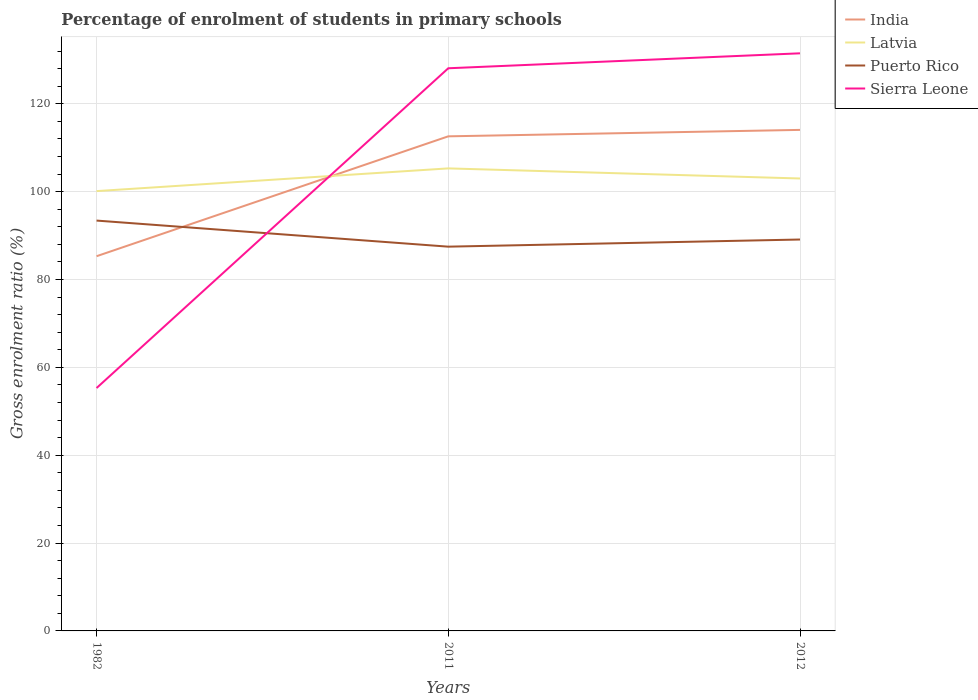Does the line corresponding to India intersect with the line corresponding to Sierra Leone?
Offer a very short reply. Yes. Is the number of lines equal to the number of legend labels?
Your response must be concise. Yes. Across all years, what is the maximum percentage of students enrolled in primary schools in Puerto Rico?
Provide a succinct answer. 87.48. What is the total percentage of students enrolled in primary schools in Latvia in the graph?
Ensure brevity in your answer.  2.3. What is the difference between the highest and the second highest percentage of students enrolled in primary schools in Puerto Rico?
Keep it short and to the point. 5.94. What is the difference between the highest and the lowest percentage of students enrolled in primary schools in India?
Keep it short and to the point. 2. Is the percentage of students enrolled in primary schools in Sierra Leone strictly greater than the percentage of students enrolled in primary schools in Latvia over the years?
Give a very brief answer. No. How many lines are there?
Keep it short and to the point. 4. How many years are there in the graph?
Your response must be concise. 3. What is the difference between two consecutive major ticks on the Y-axis?
Offer a terse response. 20. Are the values on the major ticks of Y-axis written in scientific E-notation?
Your answer should be compact. No. Does the graph contain grids?
Offer a terse response. Yes. Where does the legend appear in the graph?
Provide a succinct answer. Top right. How many legend labels are there?
Ensure brevity in your answer.  4. What is the title of the graph?
Give a very brief answer. Percentage of enrolment of students in primary schools. What is the label or title of the X-axis?
Your response must be concise. Years. What is the Gross enrolment ratio (%) in India in 1982?
Offer a very short reply. 85.3. What is the Gross enrolment ratio (%) of Latvia in 1982?
Keep it short and to the point. 100.13. What is the Gross enrolment ratio (%) of Puerto Rico in 1982?
Your answer should be compact. 93.42. What is the Gross enrolment ratio (%) of Sierra Leone in 1982?
Give a very brief answer. 55.29. What is the Gross enrolment ratio (%) of India in 2011?
Make the answer very short. 112.6. What is the Gross enrolment ratio (%) of Latvia in 2011?
Make the answer very short. 105.3. What is the Gross enrolment ratio (%) in Puerto Rico in 2011?
Your answer should be compact. 87.48. What is the Gross enrolment ratio (%) of Sierra Leone in 2011?
Provide a short and direct response. 128.09. What is the Gross enrolment ratio (%) in India in 2012?
Your answer should be compact. 114.06. What is the Gross enrolment ratio (%) in Latvia in 2012?
Offer a terse response. 103. What is the Gross enrolment ratio (%) in Puerto Rico in 2012?
Ensure brevity in your answer.  89.11. What is the Gross enrolment ratio (%) of Sierra Leone in 2012?
Your answer should be compact. 131.49. Across all years, what is the maximum Gross enrolment ratio (%) in India?
Provide a succinct answer. 114.06. Across all years, what is the maximum Gross enrolment ratio (%) in Latvia?
Give a very brief answer. 105.3. Across all years, what is the maximum Gross enrolment ratio (%) of Puerto Rico?
Keep it short and to the point. 93.42. Across all years, what is the maximum Gross enrolment ratio (%) in Sierra Leone?
Offer a terse response. 131.49. Across all years, what is the minimum Gross enrolment ratio (%) in India?
Keep it short and to the point. 85.3. Across all years, what is the minimum Gross enrolment ratio (%) in Latvia?
Your answer should be very brief. 100.13. Across all years, what is the minimum Gross enrolment ratio (%) of Puerto Rico?
Provide a succinct answer. 87.48. Across all years, what is the minimum Gross enrolment ratio (%) of Sierra Leone?
Make the answer very short. 55.29. What is the total Gross enrolment ratio (%) of India in the graph?
Provide a succinct answer. 311.96. What is the total Gross enrolment ratio (%) of Latvia in the graph?
Ensure brevity in your answer.  308.42. What is the total Gross enrolment ratio (%) in Puerto Rico in the graph?
Your answer should be very brief. 270. What is the total Gross enrolment ratio (%) of Sierra Leone in the graph?
Ensure brevity in your answer.  314.88. What is the difference between the Gross enrolment ratio (%) in India in 1982 and that in 2011?
Make the answer very short. -27.29. What is the difference between the Gross enrolment ratio (%) of Latvia in 1982 and that in 2011?
Offer a very short reply. -5.17. What is the difference between the Gross enrolment ratio (%) of Puerto Rico in 1982 and that in 2011?
Your answer should be very brief. 5.94. What is the difference between the Gross enrolment ratio (%) in Sierra Leone in 1982 and that in 2011?
Your answer should be very brief. -72.8. What is the difference between the Gross enrolment ratio (%) of India in 1982 and that in 2012?
Make the answer very short. -28.76. What is the difference between the Gross enrolment ratio (%) in Latvia in 1982 and that in 2012?
Keep it short and to the point. -2.87. What is the difference between the Gross enrolment ratio (%) of Puerto Rico in 1982 and that in 2012?
Your answer should be very brief. 4.31. What is the difference between the Gross enrolment ratio (%) of Sierra Leone in 1982 and that in 2012?
Offer a terse response. -76.2. What is the difference between the Gross enrolment ratio (%) in India in 2011 and that in 2012?
Ensure brevity in your answer.  -1.46. What is the difference between the Gross enrolment ratio (%) in Latvia in 2011 and that in 2012?
Provide a short and direct response. 2.3. What is the difference between the Gross enrolment ratio (%) of Puerto Rico in 2011 and that in 2012?
Your answer should be compact. -1.63. What is the difference between the Gross enrolment ratio (%) of Sierra Leone in 2011 and that in 2012?
Your answer should be very brief. -3.4. What is the difference between the Gross enrolment ratio (%) of India in 1982 and the Gross enrolment ratio (%) of Latvia in 2011?
Your response must be concise. -19.99. What is the difference between the Gross enrolment ratio (%) in India in 1982 and the Gross enrolment ratio (%) in Puerto Rico in 2011?
Offer a terse response. -2.17. What is the difference between the Gross enrolment ratio (%) in India in 1982 and the Gross enrolment ratio (%) in Sierra Leone in 2011?
Your answer should be very brief. -42.79. What is the difference between the Gross enrolment ratio (%) of Latvia in 1982 and the Gross enrolment ratio (%) of Puerto Rico in 2011?
Your response must be concise. 12.65. What is the difference between the Gross enrolment ratio (%) of Latvia in 1982 and the Gross enrolment ratio (%) of Sierra Leone in 2011?
Your response must be concise. -27.97. What is the difference between the Gross enrolment ratio (%) of Puerto Rico in 1982 and the Gross enrolment ratio (%) of Sierra Leone in 2011?
Offer a terse response. -34.68. What is the difference between the Gross enrolment ratio (%) in India in 1982 and the Gross enrolment ratio (%) in Latvia in 2012?
Provide a short and direct response. -17.7. What is the difference between the Gross enrolment ratio (%) of India in 1982 and the Gross enrolment ratio (%) of Puerto Rico in 2012?
Give a very brief answer. -3.8. What is the difference between the Gross enrolment ratio (%) of India in 1982 and the Gross enrolment ratio (%) of Sierra Leone in 2012?
Provide a succinct answer. -46.19. What is the difference between the Gross enrolment ratio (%) in Latvia in 1982 and the Gross enrolment ratio (%) in Puerto Rico in 2012?
Give a very brief answer. 11.02. What is the difference between the Gross enrolment ratio (%) in Latvia in 1982 and the Gross enrolment ratio (%) in Sierra Leone in 2012?
Give a very brief answer. -31.37. What is the difference between the Gross enrolment ratio (%) of Puerto Rico in 1982 and the Gross enrolment ratio (%) of Sierra Leone in 2012?
Ensure brevity in your answer.  -38.08. What is the difference between the Gross enrolment ratio (%) in India in 2011 and the Gross enrolment ratio (%) in Latvia in 2012?
Offer a very short reply. 9.6. What is the difference between the Gross enrolment ratio (%) of India in 2011 and the Gross enrolment ratio (%) of Puerto Rico in 2012?
Your answer should be compact. 23.49. What is the difference between the Gross enrolment ratio (%) in India in 2011 and the Gross enrolment ratio (%) in Sierra Leone in 2012?
Make the answer very short. -18.9. What is the difference between the Gross enrolment ratio (%) of Latvia in 2011 and the Gross enrolment ratio (%) of Puerto Rico in 2012?
Provide a short and direct response. 16.19. What is the difference between the Gross enrolment ratio (%) of Latvia in 2011 and the Gross enrolment ratio (%) of Sierra Leone in 2012?
Offer a very short reply. -26.2. What is the difference between the Gross enrolment ratio (%) of Puerto Rico in 2011 and the Gross enrolment ratio (%) of Sierra Leone in 2012?
Keep it short and to the point. -44.02. What is the average Gross enrolment ratio (%) in India per year?
Ensure brevity in your answer.  103.99. What is the average Gross enrolment ratio (%) of Latvia per year?
Offer a very short reply. 102.81. What is the average Gross enrolment ratio (%) of Puerto Rico per year?
Your answer should be compact. 90. What is the average Gross enrolment ratio (%) of Sierra Leone per year?
Provide a short and direct response. 104.96. In the year 1982, what is the difference between the Gross enrolment ratio (%) of India and Gross enrolment ratio (%) of Latvia?
Your answer should be compact. -14.82. In the year 1982, what is the difference between the Gross enrolment ratio (%) of India and Gross enrolment ratio (%) of Puerto Rico?
Provide a short and direct response. -8.11. In the year 1982, what is the difference between the Gross enrolment ratio (%) in India and Gross enrolment ratio (%) in Sierra Leone?
Keep it short and to the point. 30.01. In the year 1982, what is the difference between the Gross enrolment ratio (%) in Latvia and Gross enrolment ratio (%) in Puerto Rico?
Offer a terse response. 6.71. In the year 1982, what is the difference between the Gross enrolment ratio (%) of Latvia and Gross enrolment ratio (%) of Sierra Leone?
Your response must be concise. 44.83. In the year 1982, what is the difference between the Gross enrolment ratio (%) of Puerto Rico and Gross enrolment ratio (%) of Sierra Leone?
Make the answer very short. 38.12. In the year 2011, what is the difference between the Gross enrolment ratio (%) of India and Gross enrolment ratio (%) of Latvia?
Ensure brevity in your answer.  7.3. In the year 2011, what is the difference between the Gross enrolment ratio (%) in India and Gross enrolment ratio (%) in Puerto Rico?
Your answer should be compact. 25.12. In the year 2011, what is the difference between the Gross enrolment ratio (%) of India and Gross enrolment ratio (%) of Sierra Leone?
Give a very brief answer. -15.5. In the year 2011, what is the difference between the Gross enrolment ratio (%) of Latvia and Gross enrolment ratio (%) of Puerto Rico?
Give a very brief answer. 17.82. In the year 2011, what is the difference between the Gross enrolment ratio (%) in Latvia and Gross enrolment ratio (%) in Sierra Leone?
Give a very brief answer. -22.8. In the year 2011, what is the difference between the Gross enrolment ratio (%) of Puerto Rico and Gross enrolment ratio (%) of Sierra Leone?
Your answer should be very brief. -40.61. In the year 2012, what is the difference between the Gross enrolment ratio (%) of India and Gross enrolment ratio (%) of Latvia?
Provide a succinct answer. 11.06. In the year 2012, what is the difference between the Gross enrolment ratio (%) in India and Gross enrolment ratio (%) in Puerto Rico?
Your response must be concise. 24.95. In the year 2012, what is the difference between the Gross enrolment ratio (%) of India and Gross enrolment ratio (%) of Sierra Leone?
Offer a terse response. -17.43. In the year 2012, what is the difference between the Gross enrolment ratio (%) in Latvia and Gross enrolment ratio (%) in Puerto Rico?
Your answer should be compact. 13.89. In the year 2012, what is the difference between the Gross enrolment ratio (%) in Latvia and Gross enrolment ratio (%) in Sierra Leone?
Make the answer very short. -28.49. In the year 2012, what is the difference between the Gross enrolment ratio (%) of Puerto Rico and Gross enrolment ratio (%) of Sierra Leone?
Give a very brief answer. -42.39. What is the ratio of the Gross enrolment ratio (%) in India in 1982 to that in 2011?
Ensure brevity in your answer.  0.76. What is the ratio of the Gross enrolment ratio (%) in Latvia in 1982 to that in 2011?
Offer a very short reply. 0.95. What is the ratio of the Gross enrolment ratio (%) of Puerto Rico in 1982 to that in 2011?
Your response must be concise. 1.07. What is the ratio of the Gross enrolment ratio (%) in Sierra Leone in 1982 to that in 2011?
Provide a succinct answer. 0.43. What is the ratio of the Gross enrolment ratio (%) in India in 1982 to that in 2012?
Keep it short and to the point. 0.75. What is the ratio of the Gross enrolment ratio (%) of Latvia in 1982 to that in 2012?
Offer a very short reply. 0.97. What is the ratio of the Gross enrolment ratio (%) of Puerto Rico in 1982 to that in 2012?
Provide a succinct answer. 1.05. What is the ratio of the Gross enrolment ratio (%) in Sierra Leone in 1982 to that in 2012?
Your answer should be very brief. 0.42. What is the ratio of the Gross enrolment ratio (%) of India in 2011 to that in 2012?
Offer a very short reply. 0.99. What is the ratio of the Gross enrolment ratio (%) in Latvia in 2011 to that in 2012?
Provide a short and direct response. 1.02. What is the ratio of the Gross enrolment ratio (%) in Puerto Rico in 2011 to that in 2012?
Your response must be concise. 0.98. What is the ratio of the Gross enrolment ratio (%) in Sierra Leone in 2011 to that in 2012?
Ensure brevity in your answer.  0.97. What is the difference between the highest and the second highest Gross enrolment ratio (%) of India?
Keep it short and to the point. 1.46. What is the difference between the highest and the second highest Gross enrolment ratio (%) of Latvia?
Your answer should be very brief. 2.3. What is the difference between the highest and the second highest Gross enrolment ratio (%) in Puerto Rico?
Your answer should be very brief. 4.31. What is the difference between the highest and the second highest Gross enrolment ratio (%) in Sierra Leone?
Your answer should be very brief. 3.4. What is the difference between the highest and the lowest Gross enrolment ratio (%) of India?
Give a very brief answer. 28.76. What is the difference between the highest and the lowest Gross enrolment ratio (%) of Latvia?
Provide a short and direct response. 5.17. What is the difference between the highest and the lowest Gross enrolment ratio (%) of Puerto Rico?
Offer a very short reply. 5.94. What is the difference between the highest and the lowest Gross enrolment ratio (%) of Sierra Leone?
Your response must be concise. 76.2. 